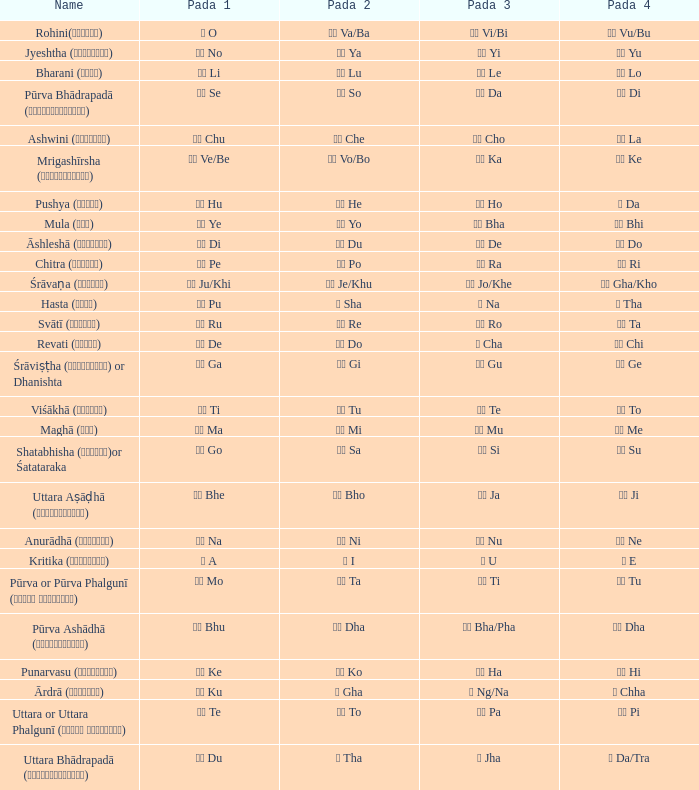Which pada 4 has a pada 2 of थ tha? ञ Da/Tra. 